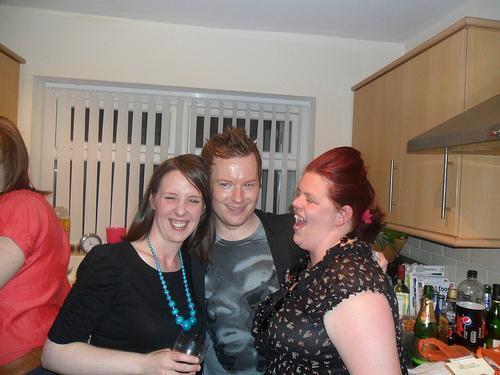How many people are smiling?
Give a very brief answer. 3. 